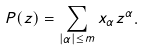<formula> <loc_0><loc_0><loc_500><loc_500>P ( z ) = \sum _ { | \alpha | \leq m } x _ { \alpha } z ^ { \alpha } .</formula> 